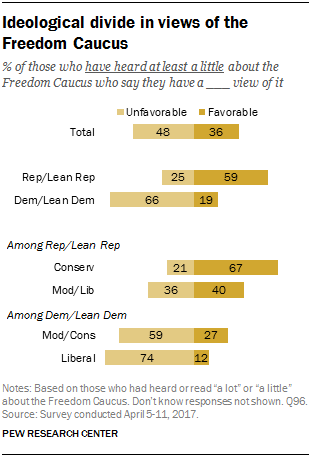Draw attention to some important aspects in this diagram. The survey indicates that 74% of respondents have an unfavorable view of liberals, while 12% have a favorable view. The bottom four-bar was added in the favorable condition, and the result was found to be greater than the total favorable value by 36. 